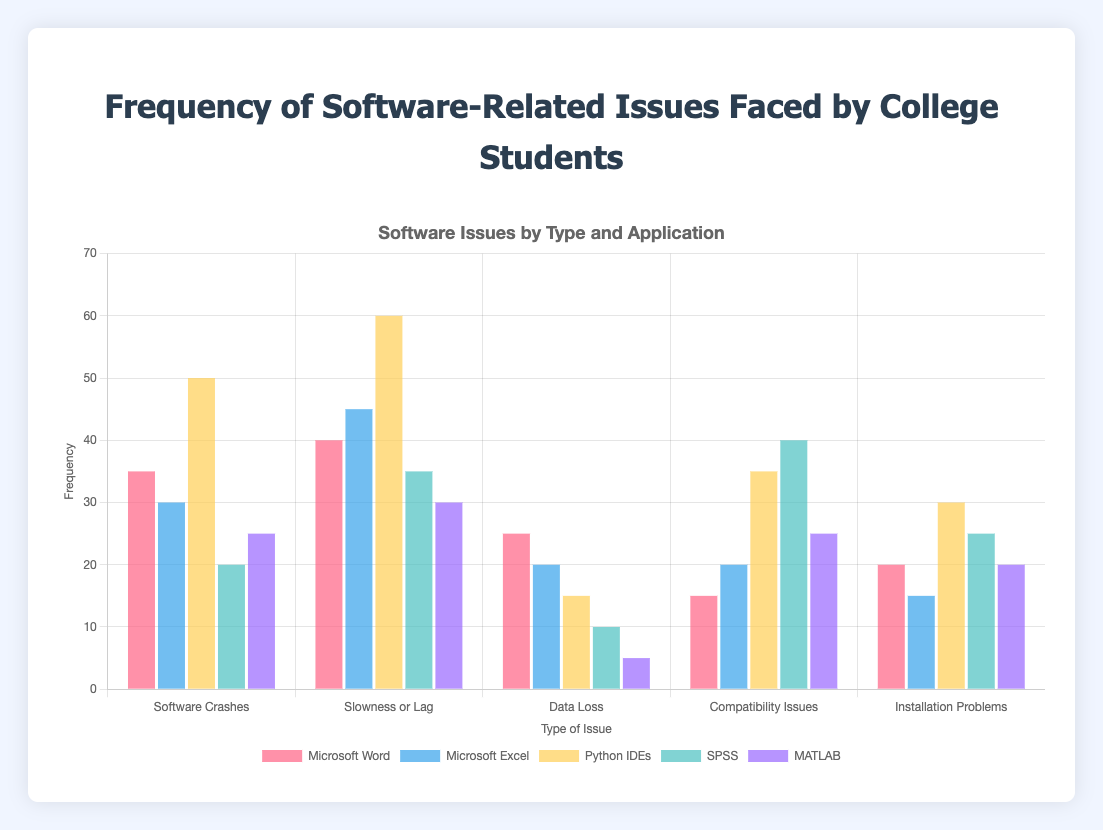What is the most frequently faced issue across all software applications? By looking at the height of all bars across the five types of issues, the highest bar corresponds to "Slowness or Lag" for Python IDEs with a frequency of 60.
Answer: Slowness or Lag For Microsoft Word, which type of issue is the least frequent? Looking at the bars for Microsoft Word across all issue types, the shortest bar is for "Compatibility Issues" with a frequency of 15.
Answer: Compatibility Issues Compare the frequency of "Installation Problems" in Python IDEs and SPSS. Which has more issues? Looking at the bars corresponding to "Installation Problems," Python IDEs have a bar height representing a frequency of 30 while SPSS has a bar height representing a frequency of 25. Python IDEs have more issues.
Answer: Python IDEs What is the total number of issues faced by MATLAB users across all issue types? Adding up all MATLAB frequencies across the five issue types: 25 (Crashes) + 30 (Slowness) + 5 (Data Loss) + 25 (Compatibility) + 20 (Installation), the total is 105.
Answer: 105 Which software application has the highest frequency of "Data Loss"? By comparing the heights of the bars for "Data Loss" across all software applications, Microsoft Word has the highest frequency of 25.
Answer: Microsoft Word What is the difference in the frequency of "Slowness or Lag" issues between Microsoft Excel and MATLAB? The frequency for Microsoft Excel's "Slowness or Lag" is 45, and for MATLAB, it is 30. The difference is 45 - 30 = 15.
Answer: 15 Compare the frequency of "Software Crashes" for Python IDEs and SPSS. How many more crashes do Python IDEs have compared to SPSS? Python IDEs have a frequency of 50 for "Software Crashes" and SPSS has 20. The difference is 50 - 20 = 30.
Answer: 30 What is the average frequency of "Compatibility Issues" across all software applications? Summing up the frequencies for "Compatibility Issues": 15 (Word) + 20 (Excel) + 35 (Python IDEs) + 40 (SPSS) + 25 (MATLAB) = 135. Dividing by 5 applications, the average is 135 / 5 = 27.
Answer: 27 What percentage of the total issues faced by SPSS are "Compatibility Issues"? Total issues for SPSS: 20 (Crashes) + 35 (Slowness) + 10 (Data Loss) + 40 (Compatibility) + 25 (Installation) = 130. Compatibility Issues are 40. Percentage is (40 / 130) * 100 ≈ 30.77%.
Answer: 30.77% Which type of issue shows the greatest variation in frequency across different software applications? By visually comparing the differences in bar heights for each type of issue, "Slowness or Lag" exhibits the largest range (from 30 to 60).
Answer: Slowness or Lag 